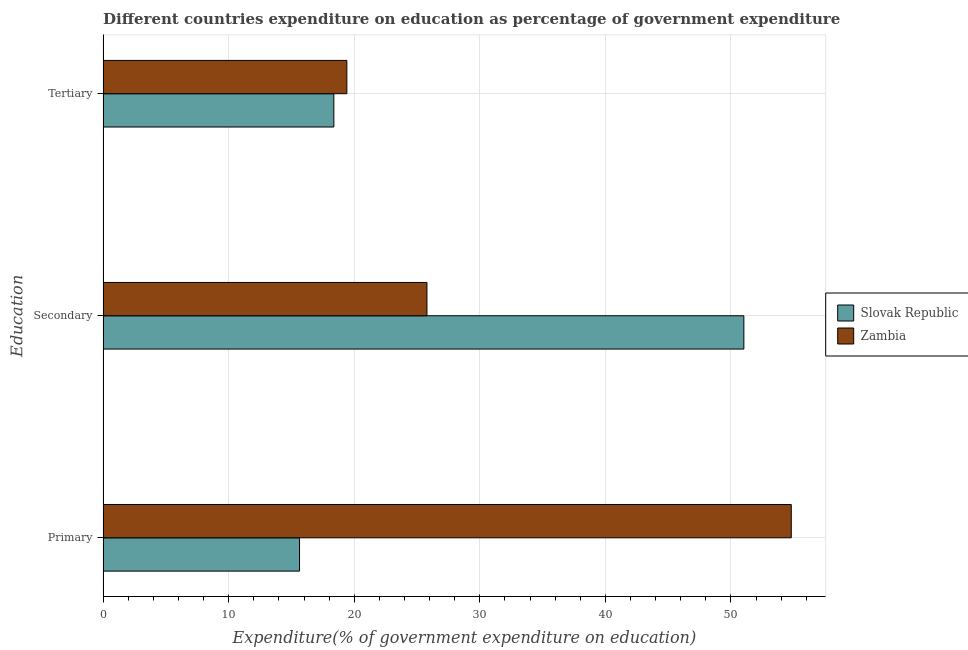Are the number of bars on each tick of the Y-axis equal?
Make the answer very short. Yes. What is the label of the 1st group of bars from the top?
Give a very brief answer. Tertiary. What is the expenditure on primary education in Slovak Republic?
Provide a succinct answer. 15.64. Across all countries, what is the maximum expenditure on tertiary education?
Make the answer very short. 19.41. Across all countries, what is the minimum expenditure on secondary education?
Ensure brevity in your answer.  25.79. In which country was the expenditure on secondary education maximum?
Keep it short and to the point. Slovak Republic. In which country was the expenditure on tertiary education minimum?
Your answer should be very brief. Slovak Republic. What is the total expenditure on secondary education in the graph?
Your answer should be compact. 76.81. What is the difference between the expenditure on tertiary education in Slovak Republic and that in Zambia?
Provide a succinct answer. -1.04. What is the difference between the expenditure on tertiary education in Zambia and the expenditure on primary education in Slovak Republic?
Your answer should be very brief. 3.77. What is the average expenditure on primary education per country?
Ensure brevity in your answer.  35.22. What is the difference between the expenditure on tertiary education and expenditure on secondary education in Slovak Republic?
Provide a short and direct response. -32.65. In how many countries, is the expenditure on tertiary education greater than 54 %?
Offer a terse response. 0. What is the ratio of the expenditure on tertiary education in Slovak Republic to that in Zambia?
Provide a succinct answer. 0.95. Is the expenditure on tertiary education in Zambia less than that in Slovak Republic?
Provide a succinct answer. No. Is the difference between the expenditure on tertiary education in Slovak Republic and Zambia greater than the difference between the expenditure on primary education in Slovak Republic and Zambia?
Make the answer very short. Yes. What is the difference between the highest and the second highest expenditure on tertiary education?
Give a very brief answer. 1.04. What is the difference between the highest and the lowest expenditure on primary education?
Offer a very short reply. 39.16. In how many countries, is the expenditure on secondary education greater than the average expenditure on secondary education taken over all countries?
Make the answer very short. 1. Is the sum of the expenditure on secondary education in Zambia and Slovak Republic greater than the maximum expenditure on tertiary education across all countries?
Offer a terse response. Yes. What does the 2nd bar from the top in Primary represents?
Keep it short and to the point. Slovak Republic. What does the 1st bar from the bottom in Primary represents?
Offer a terse response. Slovak Republic. Is it the case that in every country, the sum of the expenditure on primary education and expenditure on secondary education is greater than the expenditure on tertiary education?
Your answer should be compact. Yes. Are all the bars in the graph horizontal?
Your response must be concise. Yes. How many countries are there in the graph?
Make the answer very short. 2. Are the values on the major ticks of X-axis written in scientific E-notation?
Your answer should be very brief. No. Does the graph contain grids?
Offer a terse response. Yes. Where does the legend appear in the graph?
Provide a short and direct response. Center right. What is the title of the graph?
Your response must be concise. Different countries expenditure on education as percentage of government expenditure. What is the label or title of the X-axis?
Provide a succinct answer. Expenditure(% of government expenditure on education). What is the label or title of the Y-axis?
Give a very brief answer. Education. What is the Expenditure(% of government expenditure on education) in Slovak Republic in Primary?
Your response must be concise. 15.64. What is the Expenditure(% of government expenditure on education) of Zambia in Primary?
Offer a terse response. 54.8. What is the Expenditure(% of government expenditure on education) of Slovak Republic in Secondary?
Give a very brief answer. 51.03. What is the Expenditure(% of government expenditure on education) in Zambia in Secondary?
Provide a short and direct response. 25.79. What is the Expenditure(% of government expenditure on education) of Slovak Republic in Tertiary?
Give a very brief answer. 18.37. What is the Expenditure(% of government expenditure on education) of Zambia in Tertiary?
Offer a terse response. 19.41. Across all Education, what is the maximum Expenditure(% of government expenditure on education) in Slovak Republic?
Provide a succinct answer. 51.03. Across all Education, what is the maximum Expenditure(% of government expenditure on education) of Zambia?
Offer a very short reply. 54.8. Across all Education, what is the minimum Expenditure(% of government expenditure on education) of Slovak Republic?
Provide a succinct answer. 15.64. Across all Education, what is the minimum Expenditure(% of government expenditure on education) of Zambia?
Ensure brevity in your answer.  19.41. What is the total Expenditure(% of government expenditure on education) of Slovak Republic in the graph?
Make the answer very short. 85.04. What is the difference between the Expenditure(% of government expenditure on education) of Slovak Republic in Primary and that in Secondary?
Make the answer very short. -35.38. What is the difference between the Expenditure(% of government expenditure on education) of Zambia in Primary and that in Secondary?
Your response must be concise. 29.01. What is the difference between the Expenditure(% of government expenditure on education) of Slovak Republic in Primary and that in Tertiary?
Provide a succinct answer. -2.73. What is the difference between the Expenditure(% of government expenditure on education) of Zambia in Primary and that in Tertiary?
Offer a very short reply. 35.39. What is the difference between the Expenditure(% of government expenditure on education) of Slovak Republic in Secondary and that in Tertiary?
Make the answer very short. 32.65. What is the difference between the Expenditure(% of government expenditure on education) of Zambia in Secondary and that in Tertiary?
Offer a very short reply. 6.38. What is the difference between the Expenditure(% of government expenditure on education) of Slovak Republic in Primary and the Expenditure(% of government expenditure on education) of Zambia in Secondary?
Provide a succinct answer. -10.15. What is the difference between the Expenditure(% of government expenditure on education) of Slovak Republic in Primary and the Expenditure(% of government expenditure on education) of Zambia in Tertiary?
Keep it short and to the point. -3.77. What is the difference between the Expenditure(% of government expenditure on education) in Slovak Republic in Secondary and the Expenditure(% of government expenditure on education) in Zambia in Tertiary?
Provide a succinct answer. 31.62. What is the average Expenditure(% of government expenditure on education) in Slovak Republic per Education?
Ensure brevity in your answer.  28.35. What is the average Expenditure(% of government expenditure on education) in Zambia per Education?
Keep it short and to the point. 33.33. What is the difference between the Expenditure(% of government expenditure on education) in Slovak Republic and Expenditure(% of government expenditure on education) in Zambia in Primary?
Your answer should be very brief. -39.16. What is the difference between the Expenditure(% of government expenditure on education) of Slovak Republic and Expenditure(% of government expenditure on education) of Zambia in Secondary?
Offer a very short reply. 25.24. What is the difference between the Expenditure(% of government expenditure on education) in Slovak Republic and Expenditure(% of government expenditure on education) in Zambia in Tertiary?
Provide a short and direct response. -1.04. What is the ratio of the Expenditure(% of government expenditure on education) of Slovak Republic in Primary to that in Secondary?
Provide a short and direct response. 0.31. What is the ratio of the Expenditure(% of government expenditure on education) in Zambia in Primary to that in Secondary?
Keep it short and to the point. 2.13. What is the ratio of the Expenditure(% of government expenditure on education) of Slovak Republic in Primary to that in Tertiary?
Make the answer very short. 0.85. What is the ratio of the Expenditure(% of government expenditure on education) in Zambia in Primary to that in Tertiary?
Make the answer very short. 2.82. What is the ratio of the Expenditure(% of government expenditure on education) in Slovak Republic in Secondary to that in Tertiary?
Offer a terse response. 2.78. What is the ratio of the Expenditure(% of government expenditure on education) of Zambia in Secondary to that in Tertiary?
Provide a succinct answer. 1.33. What is the difference between the highest and the second highest Expenditure(% of government expenditure on education) of Slovak Republic?
Offer a terse response. 32.65. What is the difference between the highest and the second highest Expenditure(% of government expenditure on education) of Zambia?
Keep it short and to the point. 29.01. What is the difference between the highest and the lowest Expenditure(% of government expenditure on education) in Slovak Republic?
Keep it short and to the point. 35.38. What is the difference between the highest and the lowest Expenditure(% of government expenditure on education) in Zambia?
Your answer should be compact. 35.39. 